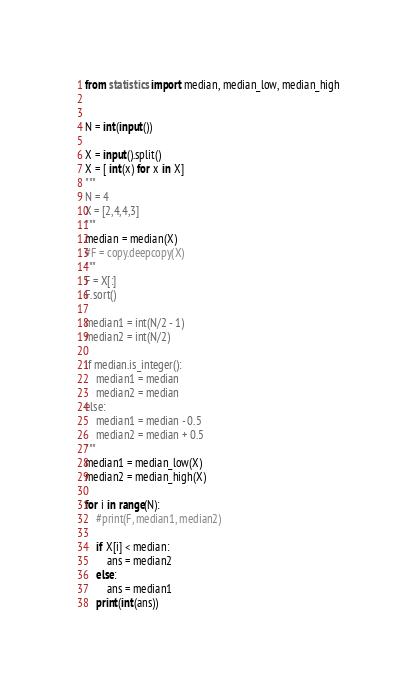Convert code to text. <code><loc_0><loc_0><loc_500><loc_500><_Python_>from statistics import median, median_low, median_high


N = int(input())

X = input().split()
X = [ int(x) for x in X]
"""
N = 4
X = [2,4,4,3]
"""
median = median(X)
#F = copy.deepcopy(X)
"""
F = X[:]
F.sort()

median1 = int(N/2 - 1)
median2 = int(N/2) 

if median.is_integer():
    median1 = median
    median2 = median
else:
    median1 = median - 0.5
    median2 = median + 0.5
"""
median1 = median_low(X)
median2 = median_high(X)
   
for i in range(N):
    #print(F, median1, median2)
    
    if X[i] < median:
        ans = median2
    else:
        ans = median1
    print(int(ans))</code> 